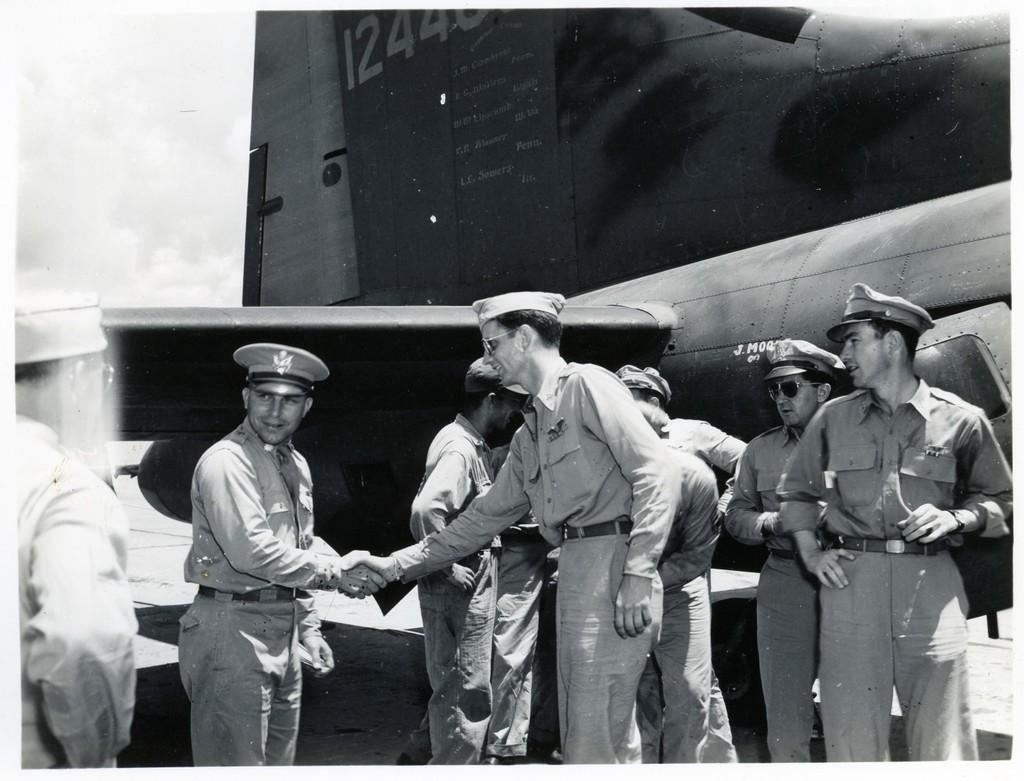What is happening in the image? There is a group of people standing in the image. What can be seen in the background of the image? There is an aircraft and the sky visible in the background of the image. How is the image presented? The image is in black and white. What type of cart is being used to transport the cabbage in the image? There is no cart or cabbage present in the image. What unit of measurement is being used to determine the size of the unit in the image? There is no unit or measurement mentioned in the image. 